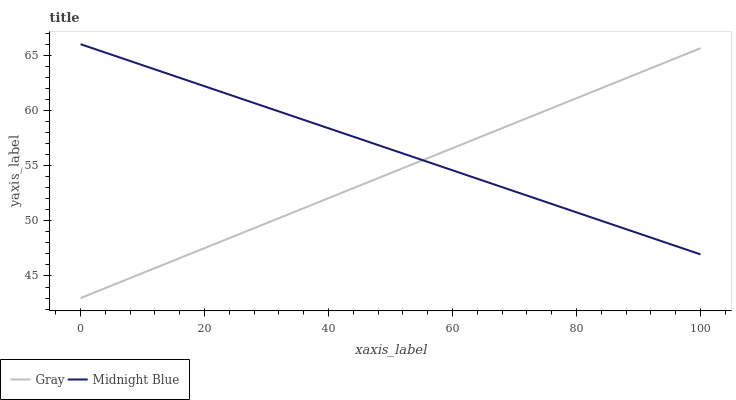Does Midnight Blue have the minimum area under the curve?
Answer yes or no. No. Is Midnight Blue the roughest?
Answer yes or no. No. Does Midnight Blue have the lowest value?
Answer yes or no. No. 